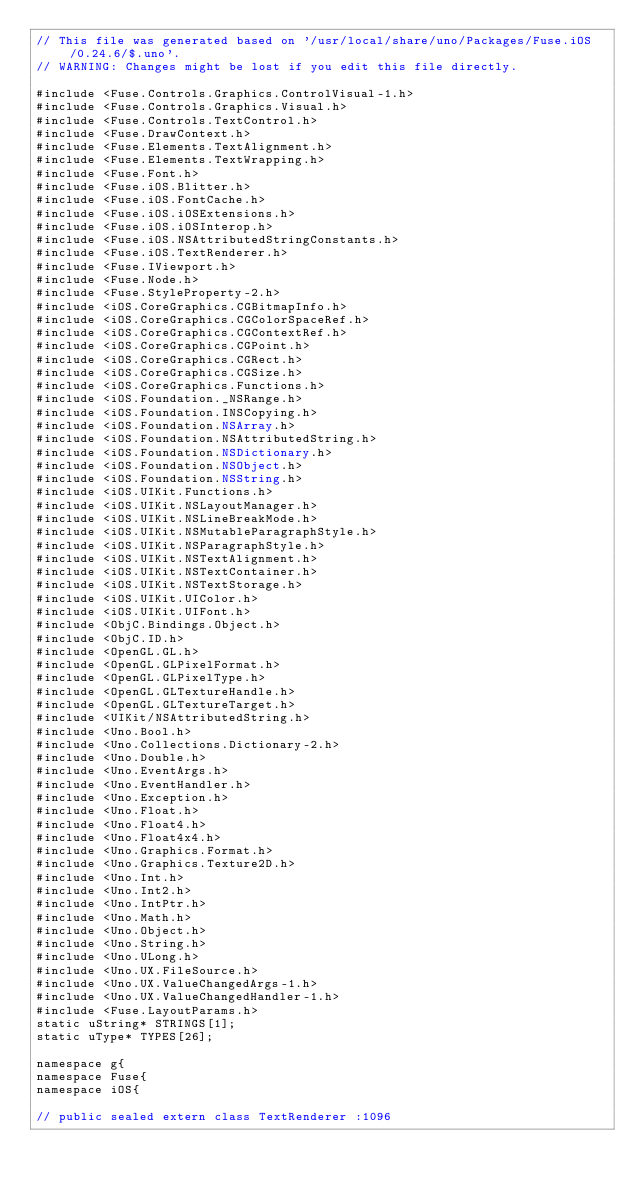<code> <loc_0><loc_0><loc_500><loc_500><_ObjectiveC_>// This file was generated based on '/usr/local/share/uno/Packages/Fuse.iOS/0.24.6/$.uno'.
// WARNING: Changes might be lost if you edit this file directly.

#include <Fuse.Controls.Graphics.ControlVisual-1.h>
#include <Fuse.Controls.Graphics.Visual.h>
#include <Fuse.Controls.TextControl.h>
#include <Fuse.DrawContext.h>
#include <Fuse.Elements.TextAlignment.h>
#include <Fuse.Elements.TextWrapping.h>
#include <Fuse.Font.h>
#include <Fuse.iOS.Blitter.h>
#include <Fuse.iOS.FontCache.h>
#include <Fuse.iOS.iOSExtensions.h>
#include <Fuse.iOS.iOSInterop.h>
#include <Fuse.iOS.NSAttributedStringConstants.h>
#include <Fuse.iOS.TextRenderer.h>
#include <Fuse.IViewport.h>
#include <Fuse.Node.h>
#include <Fuse.StyleProperty-2.h>
#include <iOS.CoreGraphics.CGBitmapInfo.h>
#include <iOS.CoreGraphics.CGColorSpaceRef.h>
#include <iOS.CoreGraphics.CGContextRef.h>
#include <iOS.CoreGraphics.CGPoint.h>
#include <iOS.CoreGraphics.CGRect.h>
#include <iOS.CoreGraphics.CGSize.h>
#include <iOS.CoreGraphics.Functions.h>
#include <iOS.Foundation._NSRange.h>
#include <iOS.Foundation.INSCopying.h>
#include <iOS.Foundation.NSArray.h>
#include <iOS.Foundation.NSAttributedString.h>
#include <iOS.Foundation.NSDictionary.h>
#include <iOS.Foundation.NSObject.h>
#include <iOS.Foundation.NSString.h>
#include <iOS.UIKit.Functions.h>
#include <iOS.UIKit.NSLayoutManager.h>
#include <iOS.UIKit.NSLineBreakMode.h>
#include <iOS.UIKit.NSMutableParagraphStyle.h>
#include <iOS.UIKit.NSParagraphStyle.h>
#include <iOS.UIKit.NSTextAlignment.h>
#include <iOS.UIKit.NSTextContainer.h>
#include <iOS.UIKit.NSTextStorage.h>
#include <iOS.UIKit.UIColor.h>
#include <iOS.UIKit.UIFont.h>
#include <ObjC.Bindings.Object.h>
#include <ObjC.ID.h>
#include <OpenGL.GL.h>
#include <OpenGL.GLPixelFormat.h>
#include <OpenGL.GLPixelType.h>
#include <OpenGL.GLTextureHandle.h>
#include <OpenGL.GLTextureTarget.h>
#include <UIKit/NSAttributedString.h>
#include <Uno.Bool.h>
#include <Uno.Collections.Dictionary-2.h>
#include <Uno.Double.h>
#include <Uno.EventArgs.h>
#include <Uno.EventHandler.h>
#include <Uno.Exception.h>
#include <Uno.Float.h>
#include <Uno.Float4.h>
#include <Uno.Float4x4.h>
#include <Uno.Graphics.Format.h>
#include <Uno.Graphics.Texture2D.h>
#include <Uno.Int.h>
#include <Uno.Int2.h>
#include <Uno.IntPtr.h>
#include <Uno.Math.h>
#include <Uno.Object.h>
#include <Uno.String.h>
#include <Uno.ULong.h>
#include <Uno.UX.FileSource.h>
#include <Uno.UX.ValueChangedArgs-1.h>
#include <Uno.UX.ValueChangedHandler-1.h>
#include <Fuse.LayoutParams.h>
static uString* STRINGS[1];
static uType* TYPES[26];

namespace g{
namespace Fuse{
namespace iOS{

// public sealed extern class TextRenderer :1096</code> 